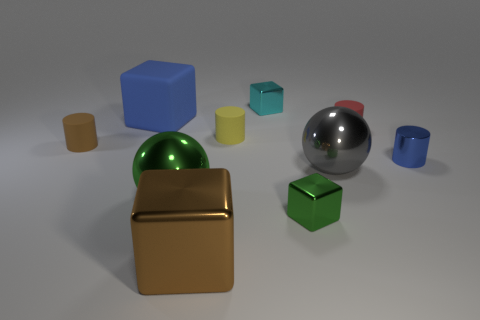Is there a tiny cyan metal thing? Yes, there is a tiny cyan metal cube among the various objects in the image. It appears to have a smooth surface, reflecting some light which indicates its metallic nature. 